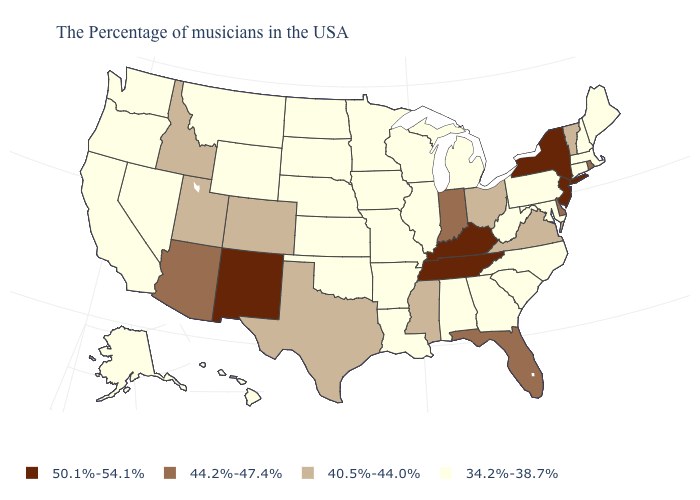What is the lowest value in states that border North Dakota?
Answer briefly. 34.2%-38.7%. What is the value of Pennsylvania?
Short answer required. 34.2%-38.7%. Name the states that have a value in the range 40.5%-44.0%?
Concise answer only. Vermont, Virginia, Ohio, Mississippi, Texas, Colorado, Utah, Idaho. What is the value of Montana?
Concise answer only. 34.2%-38.7%. Among the states that border Oklahoma , does Missouri have the lowest value?
Be succinct. Yes. What is the value of Delaware?
Write a very short answer. 44.2%-47.4%. Which states hav the highest value in the South?
Answer briefly. Kentucky, Tennessee. Name the states that have a value in the range 34.2%-38.7%?
Write a very short answer. Maine, Massachusetts, New Hampshire, Connecticut, Maryland, Pennsylvania, North Carolina, South Carolina, West Virginia, Georgia, Michigan, Alabama, Wisconsin, Illinois, Louisiana, Missouri, Arkansas, Minnesota, Iowa, Kansas, Nebraska, Oklahoma, South Dakota, North Dakota, Wyoming, Montana, Nevada, California, Washington, Oregon, Alaska, Hawaii. Name the states that have a value in the range 50.1%-54.1%?
Write a very short answer. New York, New Jersey, Kentucky, Tennessee, New Mexico. What is the value of Louisiana?
Write a very short answer. 34.2%-38.7%. What is the lowest value in the USA?
Answer briefly. 34.2%-38.7%. Does Oregon have a higher value than Maine?
Answer briefly. No. Does the first symbol in the legend represent the smallest category?
Give a very brief answer. No. Does Georgia have the same value as Virginia?
Answer briefly. No. 